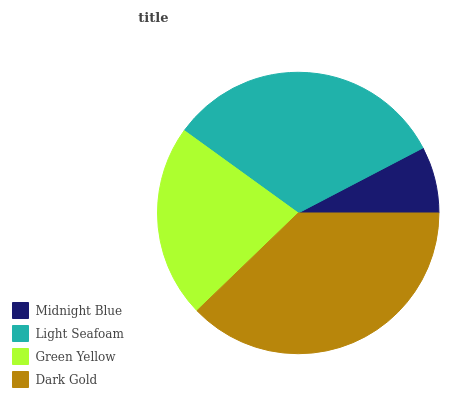Is Midnight Blue the minimum?
Answer yes or no. Yes. Is Dark Gold the maximum?
Answer yes or no. Yes. Is Light Seafoam the minimum?
Answer yes or no. No. Is Light Seafoam the maximum?
Answer yes or no. No. Is Light Seafoam greater than Midnight Blue?
Answer yes or no. Yes. Is Midnight Blue less than Light Seafoam?
Answer yes or no. Yes. Is Midnight Blue greater than Light Seafoam?
Answer yes or no. No. Is Light Seafoam less than Midnight Blue?
Answer yes or no. No. Is Light Seafoam the high median?
Answer yes or no. Yes. Is Green Yellow the low median?
Answer yes or no. Yes. Is Green Yellow the high median?
Answer yes or no. No. Is Midnight Blue the low median?
Answer yes or no. No. 